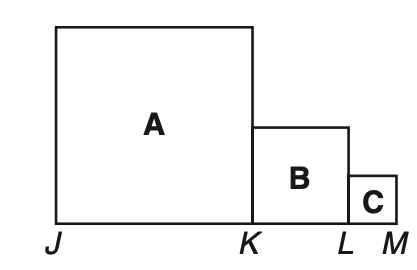Question: In the figure consisting of squares A, B, and C, J K = 2K L and K L = 2L M. If the perimeter of the figure is 66 units, what is the area?
Choices:
A. 117
B. 189
C. 224
D. 258
Answer with the letter. Answer: B 